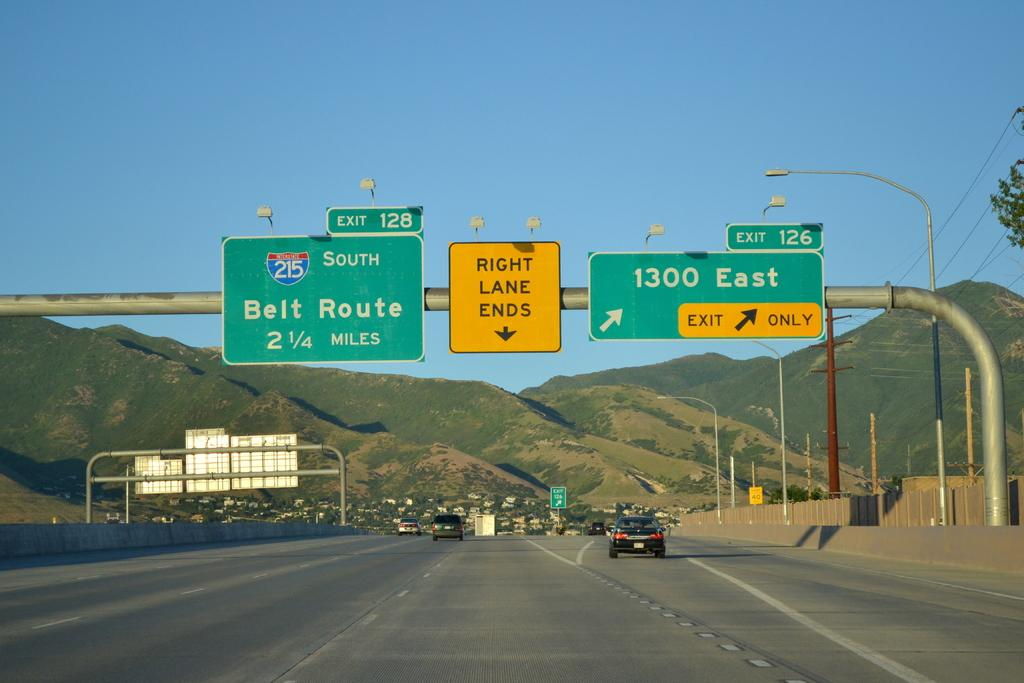<image>
Create a compact narrative representing the image presented. Highway signs with one pointing to Belt Route and the other to 1300 East. 